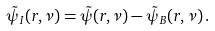Convert formula to latex. <formula><loc_0><loc_0><loc_500><loc_500>\tilde { \psi } _ { I } ( r , \nu ) = \tilde { \psi } ( r , \nu ) - \tilde { \psi } _ { B } ( r , \nu ) \, .</formula> 